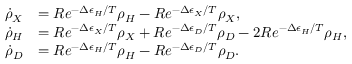Convert formula to latex. <formula><loc_0><loc_0><loc_500><loc_500>\begin{array} { r l } { \dot { \rho } _ { X } } & { = R e ^ { - \Delta \epsilon _ { H } / T } \rho _ { H } - R e ^ { - \Delta \epsilon _ { X } / T } \rho _ { X } , } \\ { \dot { \rho } _ { H } } & { = R e ^ { - \Delta \epsilon _ { X } / T } \rho _ { X } + R e ^ { - \Delta \epsilon _ { D } / T } \rho _ { D } - 2 R e ^ { - \Delta \epsilon _ { H } / T } \rho _ { H } , } \\ { \dot { \rho } _ { D } } & { = R e ^ { - \Delta \epsilon _ { H } / T } \rho _ { H } - R e ^ { - \Delta \epsilon _ { D } / T } \rho _ { D } . } \end{array}</formula> 